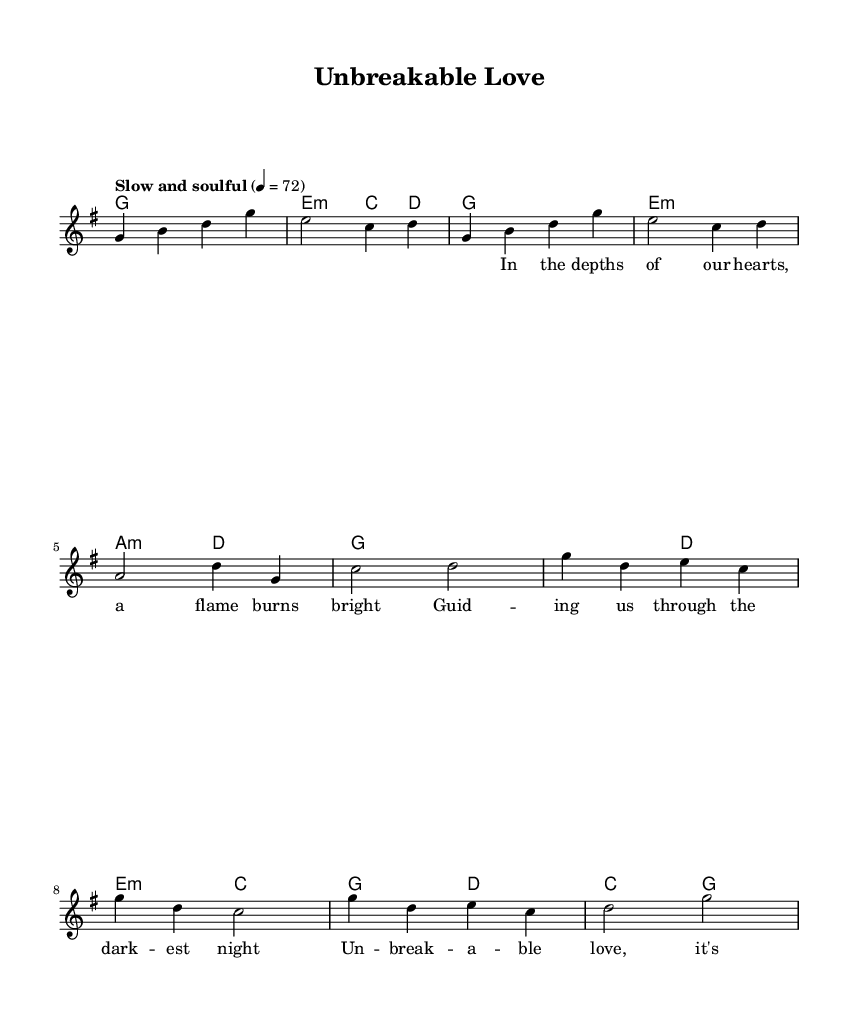What is the key signature of this music? The key signature is G major, which has one sharp (F#). This is indicated by the presence of the 'g' note in the melody and the chord progression that centers around G major chords.
Answer: G major What is the time signature of this music? The time signature is 4/4, which is shown at the beginning of the score next to the key signature. This indicates there are four beats in each measure.
Answer: 4/4 What is the tempo marking for this piece? The tempo marking is "Slow and soulful," which indicates the feel and speed at which the piece should be played. This is usually found near the beginning of the sheet music.
Answer: Slow and soulful How many measures are present in the chorus section? The chorus section consists of 4 measures, as evidenced by the notations in the melody and chord section during that part of the song. Each measure has a defined beginning and end for the notes present.
Answer: 4 What is the primary theme conveyed through the lyrics of this piece? The primary theme of the lyrics is "unbreakable love," which focuses on familial strength and support in the face of challenges. This can be deduced from the repeated phrases in the chorus and verses.
Answer: Unbreakable love What is the last chord in the piece? The last chord is G major, which wraps up the piece harmonically. It signifies the conclusion and resolution of the musical ideas presented in the composition.
Answer: G 